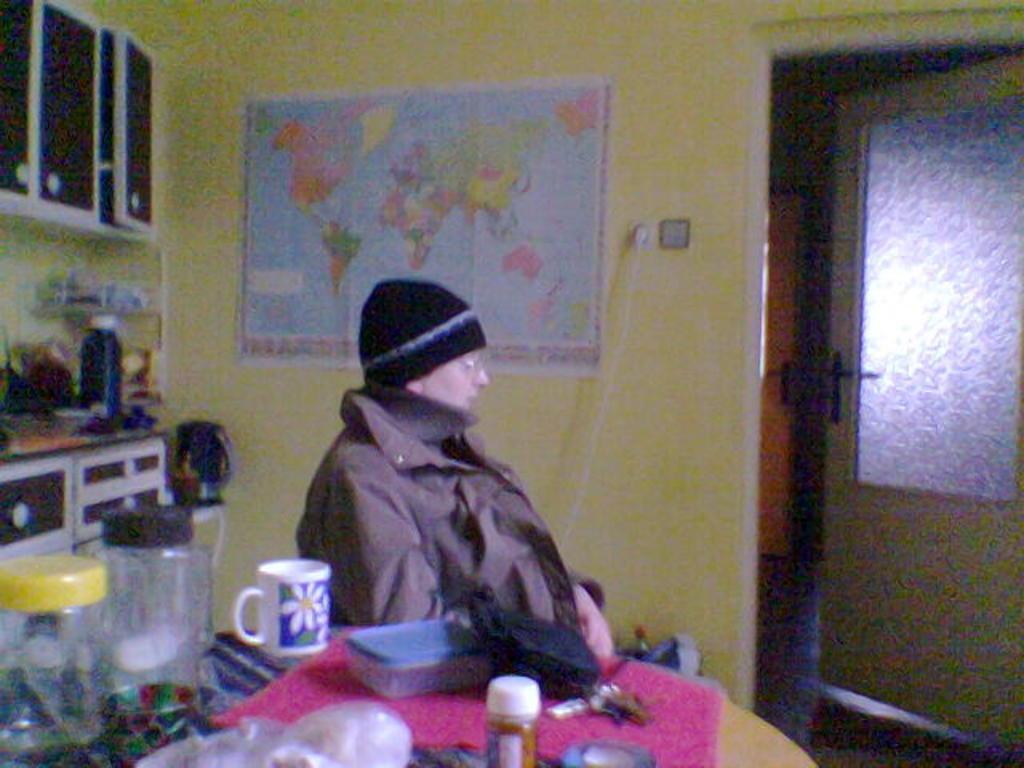Can you describe this image briefly? We can see a person and there is a cap on the head. At the bottom there are jars,cup,cloth,box and other objects on a table. In the background there is a map on the wall,cupboards,objects on a table and on the right side there is a door and floor. 